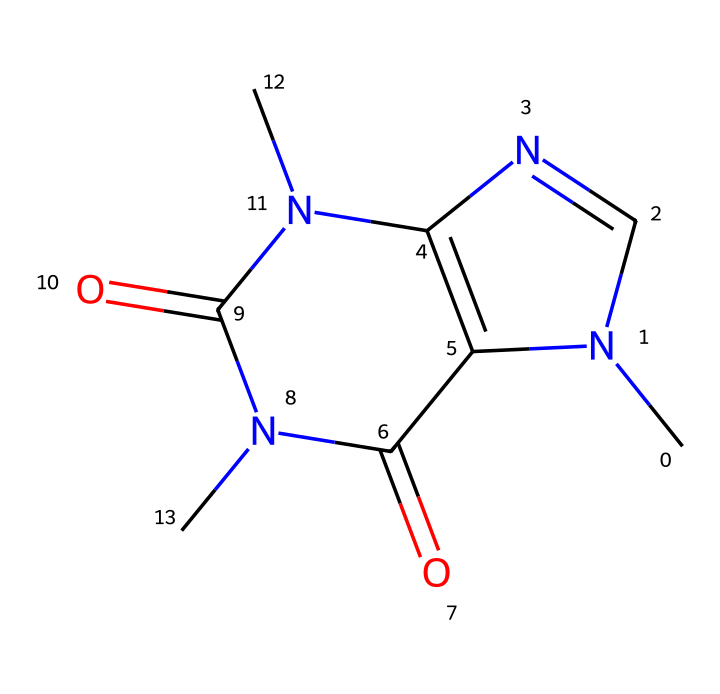What is the name of this chemical? The SMILES representation corresponds to caffeine, which is commonly found in tea and coffee. By interpreting the SMILES, we recognize its structure as consistent with caffeine's known chemical identity.
Answer: caffeine How many nitrogen atoms are present in the structure? Analyzing the SMILES representation, we identify three nitrogen atoms (N) in the compound. Counting them shows that nitrogen contributes to the unique properties of caffeine.
Answer: three What type of chemical structure does caffeine represent? Caffeine is classified as an alkaloid due to its nitrogen-containing structure, which contributes to its pharmacological effects. The presence of multiple nitrogen atoms indicates that it belongs to this category of compounds.
Answer: alkaloid What is the molecular formula of caffeine? By interpreting the structure represented in the SMILES notation, we can determine that caffeine's molecular formula is C8H10N4O2, encompassing eight carbon atoms, ten hydrogen atoms, four nitrogen atoms, and two oxygen atoms in total.
Answer: C8H10N4O2 What potential hazards are associated with caffeine consumption? Caffeine can lead to increased heart rate, anxiety, and restlessness when consumed in excessive amounts. Understanding the chemical structure allows us to relate these effects to its stimulant properties.
Answer: stimulant effects How many rings are in the caffeine structure? The structure contains two distinct rings; one is a six-membered and the other is a five-membered ring, which demonstrate its bicyclic nature. This is apparent from the connectivity shown in the SMILES representation and is characteristic of caffeine.
Answer: two 